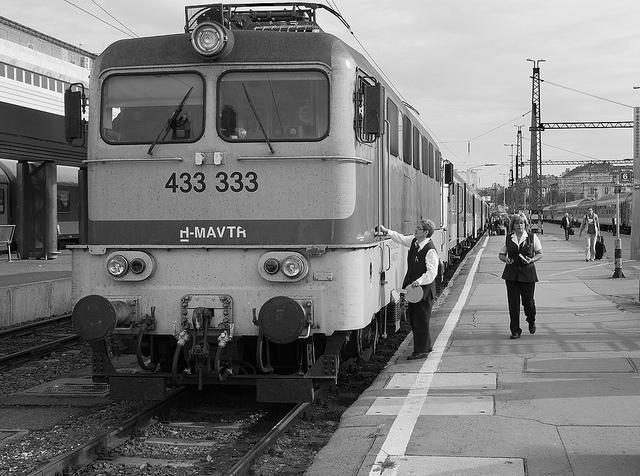How many people are there?
Give a very brief answer. 2. How many trains can you see?
Give a very brief answer. 2. How many surfboards are there?
Give a very brief answer. 0. 